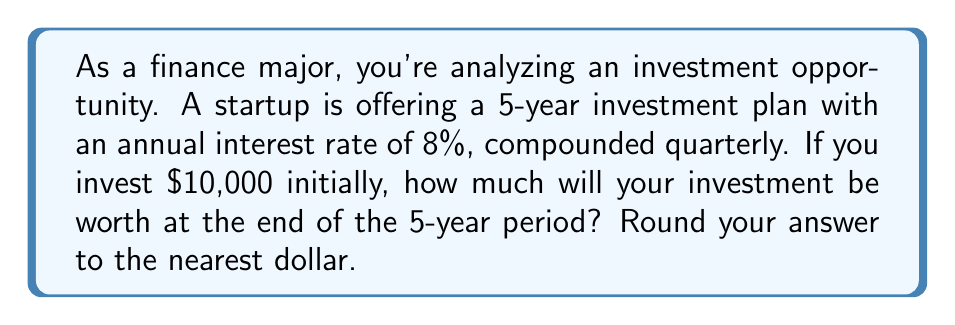Teach me how to tackle this problem. To solve this problem, we'll use the compound interest formula:

$$A = P(1 + \frac{r}{n})^{nt}$$

Where:
$A$ = Final amount
$P$ = Principal (initial investment)
$r$ = Annual interest rate (as a decimal)
$n$ = Number of times interest is compounded per year
$t$ = Number of years

Given:
$P = \$10,000$
$r = 0.08$ (8% expressed as a decimal)
$n = 4$ (compounded quarterly, so 4 times per year)
$t = 5$ years

Let's substitute these values into the formula:

$$A = 10000(1 + \frac{0.08}{4})^{4 \times 5}$$

$$A = 10000(1 + 0.02)^{20}$$

$$A = 10000(1.02)^{20}$$

Now, let's calculate this:

$$A = 10000 \times 1.4859468...$$

$$A = 14859.47...$$

Rounding to the nearest dollar:

$$A = \$14,859$$
Answer: $14,859 